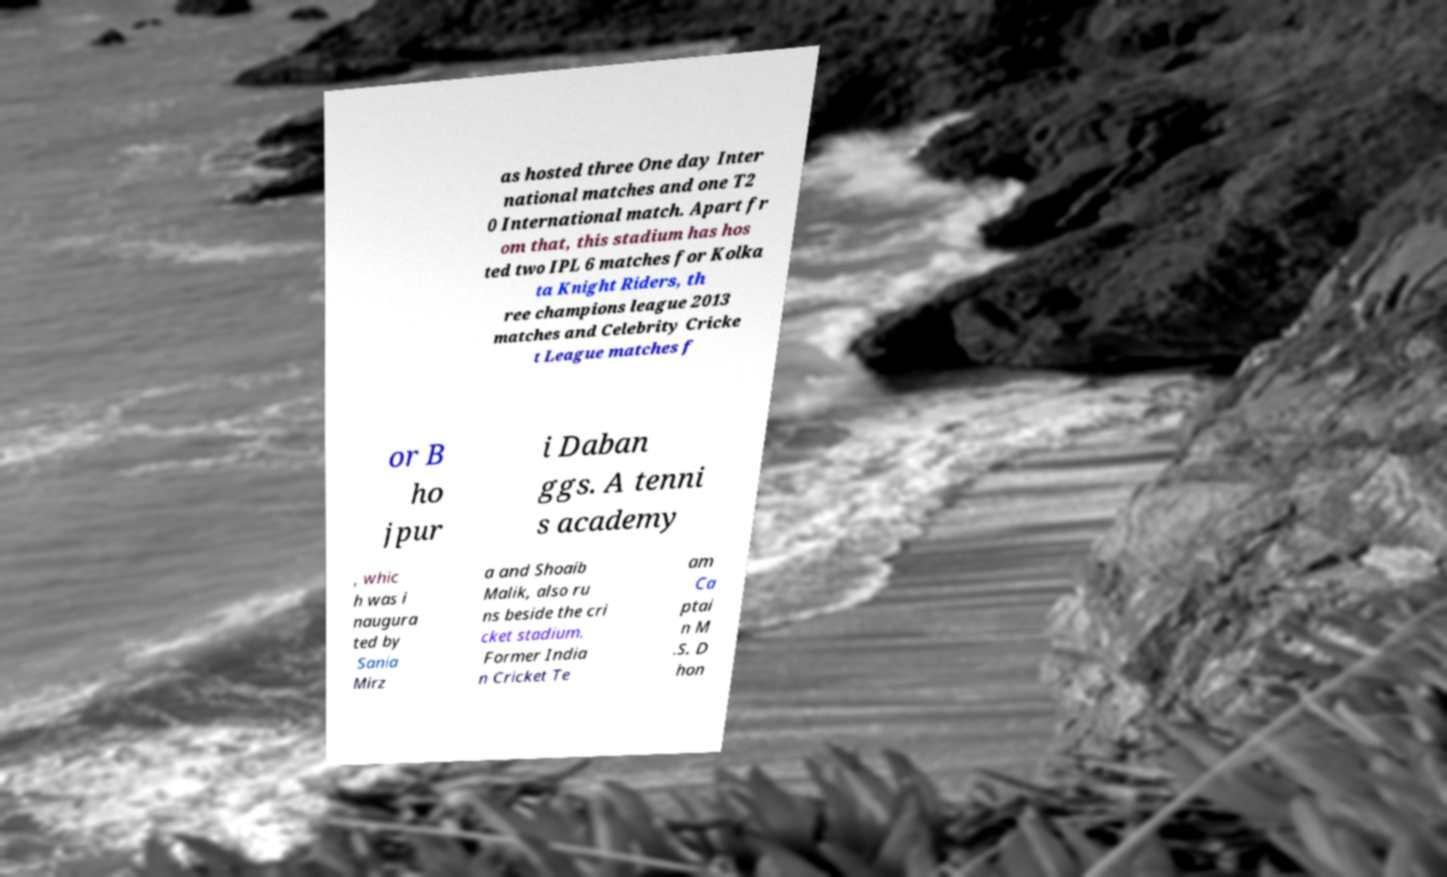Could you extract and type out the text from this image? as hosted three One day Inter national matches and one T2 0 International match. Apart fr om that, this stadium has hos ted two IPL 6 matches for Kolka ta Knight Riders, th ree champions league 2013 matches and Celebrity Cricke t League matches f or B ho jpur i Daban ggs. A tenni s academy , whic h was i naugura ted by Sania Mirz a and Shoaib Malik, also ru ns beside the cri cket stadium. Former India n Cricket Te am Ca ptai n M .S. D hon 